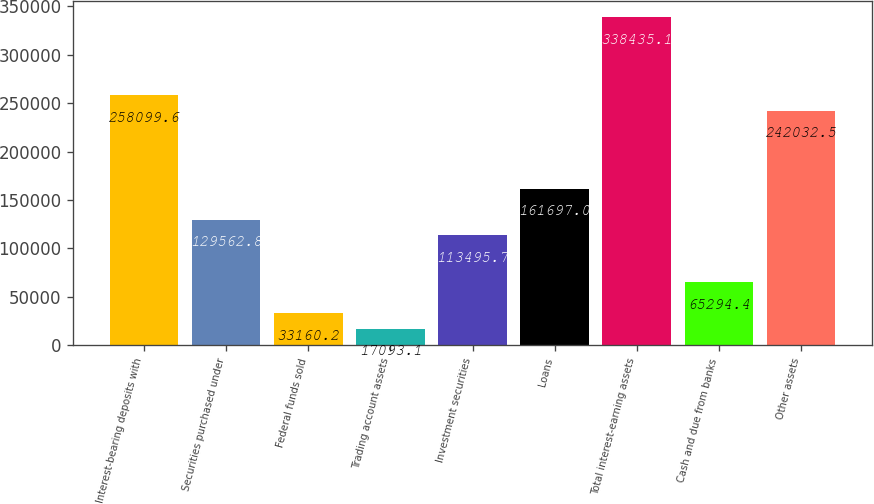Convert chart to OTSL. <chart><loc_0><loc_0><loc_500><loc_500><bar_chart><fcel>Interest-bearing deposits with<fcel>Securities purchased under<fcel>Federal funds sold<fcel>Trading account assets<fcel>Investment securities<fcel>Loans<fcel>Total interest-earning assets<fcel>Cash and due from banks<fcel>Other assets<nl><fcel>258100<fcel>129563<fcel>33160.2<fcel>17093.1<fcel>113496<fcel>161697<fcel>338435<fcel>65294.4<fcel>242032<nl></chart> 